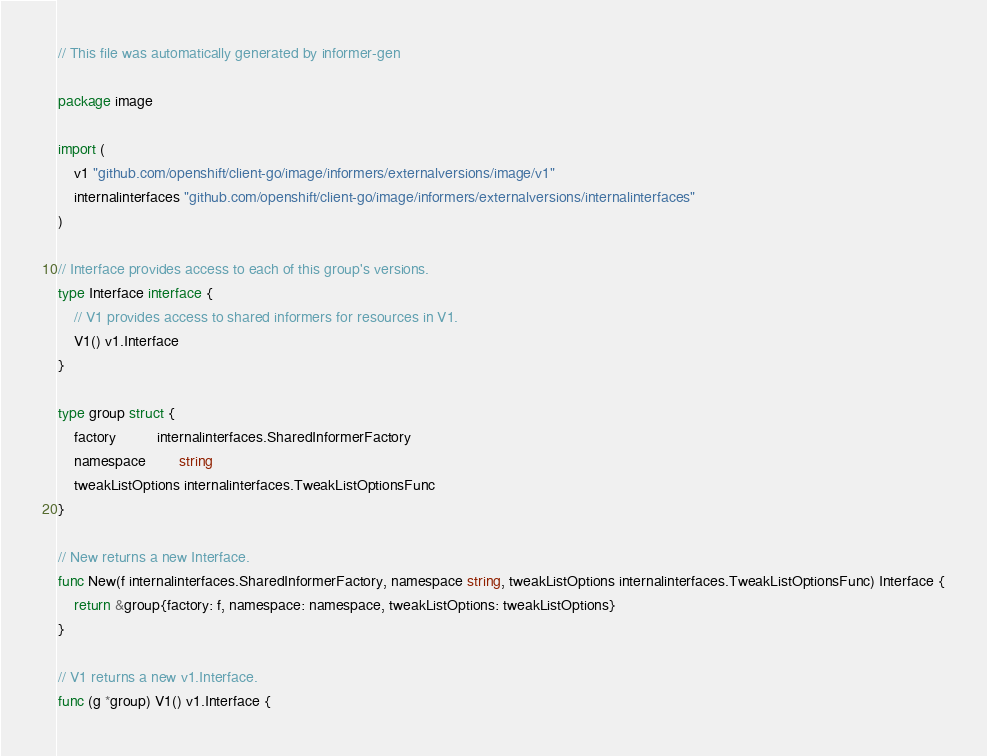<code> <loc_0><loc_0><loc_500><loc_500><_Go_>// This file was automatically generated by informer-gen

package image

import (
	v1 "github.com/openshift/client-go/image/informers/externalversions/image/v1"
	internalinterfaces "github.com/openshift/client-go/image/informers/externalversions/internalinterfaces"
)

// Interface provides access to each of this group's versions.
type Interface interface {
	// V1 provides access to shared informers for resources in V1.
	V1() v1.Interface
}

type group struct {
	factory          internalinterfaces.SharedInformerFactory
	namespace        string
	tweakListOptions internalinterfaces.TweakListOptionsFunc
}

// New returns a new Interface.
func New(f internalinterfaces.SharedInformerFactory, namespace string, tweakListOptions internalinterfaces.TweakListOptionsFunc) Interface {
	return &group{factory: f, namespace: namespace, tweakListOptions: tweakListOptions}
}

// V1 returns a new v1.Interface.
func (g *group) V1() v1.Interface {</code> 